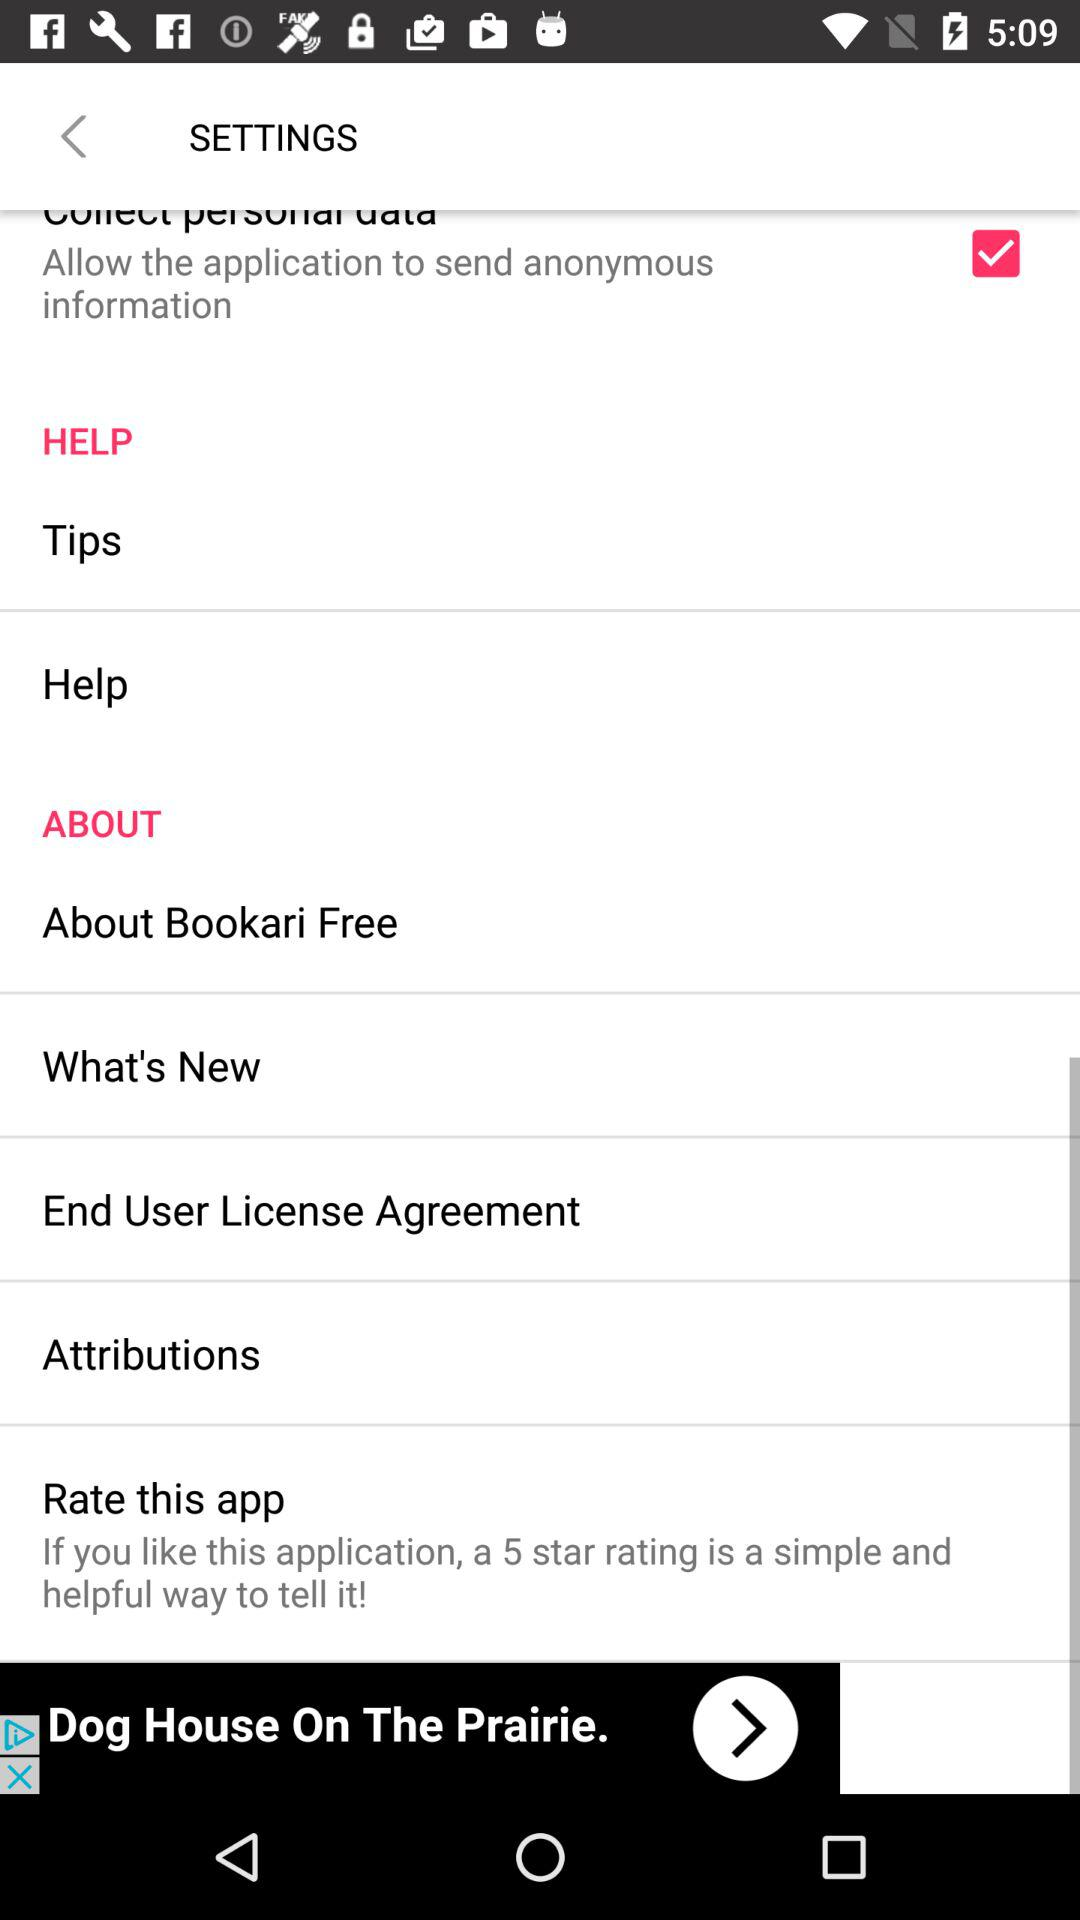If we like the application, what rating can we give? We can give a 5 star rating. 